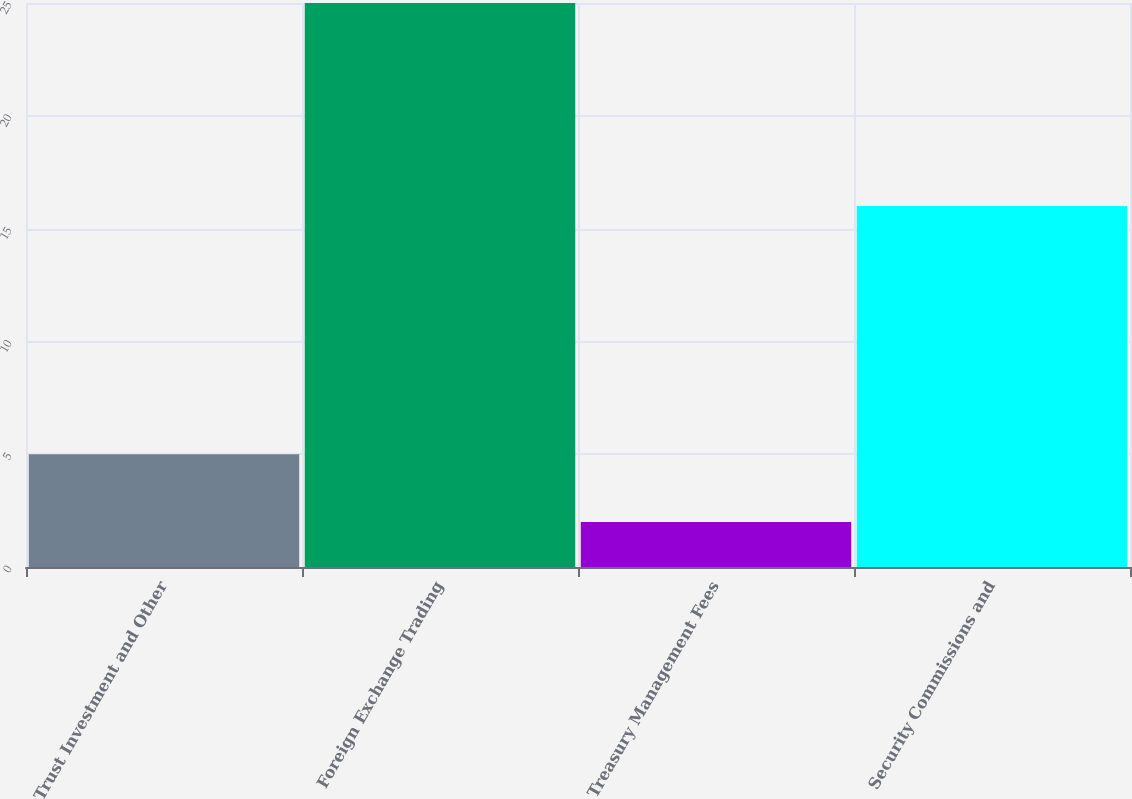Convert chart. <chart><loc_0><loc_0><loc_500><loc_500><bar_chart><fcel>Trust Investment and Other<fcel>Foreign Exchange Trading<fcel>Treasury Management Fees<fcel>Security Commissions and<nl><fcel>5<fcel>25<fcel>2<fcel>16<nl></chart> 